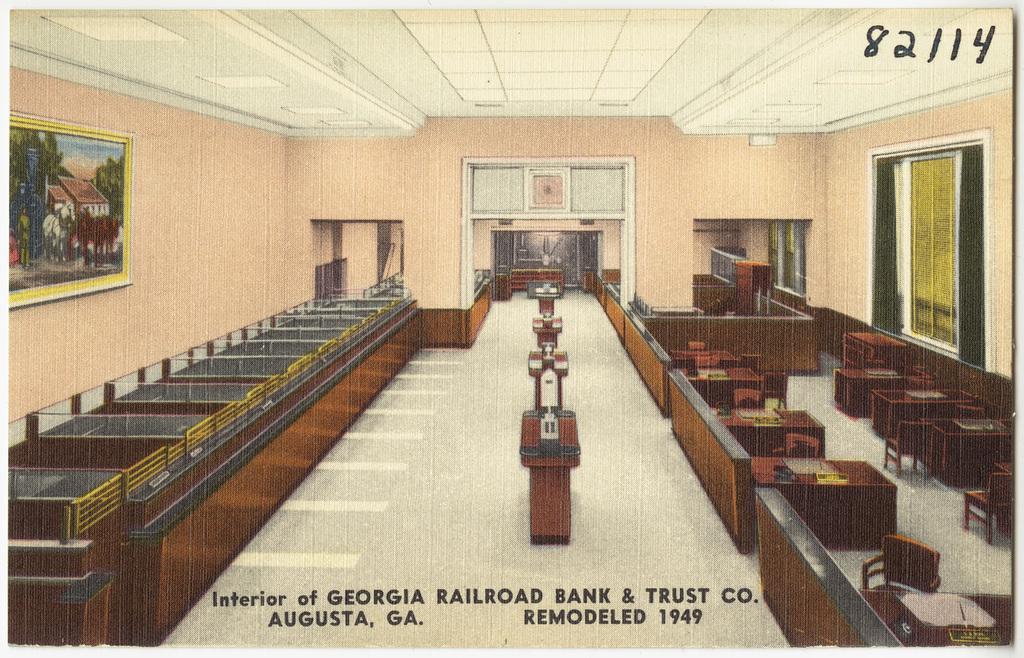Please provide a concise description of this image. This picture is clicked inside seems to be an edited image. In the center we can see the tables on the top of which some items are placed. On the right we can see the chairs and the tables containing some items. On the left there is a wooden desk. In the background we can see the wall and the picture frame hanging on the wall, we can see a window and some other items. At the top there is a roof and the text on the image. 